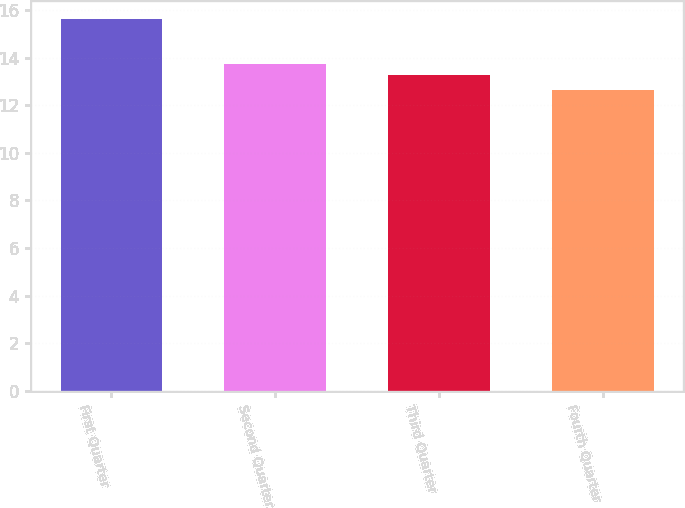<chart> <loc_0><loc_0><loc_500><loc_500><bar_chart><fcel>First Quarter<fcel>Second Quarter<fcel>Third Quarter<fcel>Fourth Quarter<nl><fcel>15.61<fcel>13.75<fcel>13.29<fcel>12.62<nl></chart> 